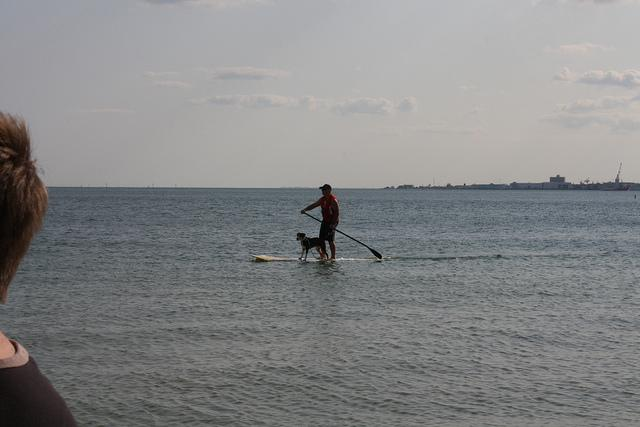What type of vehicle is present in the water?

Choices:
A) board
B) bicycle
C) truck
D) car board 